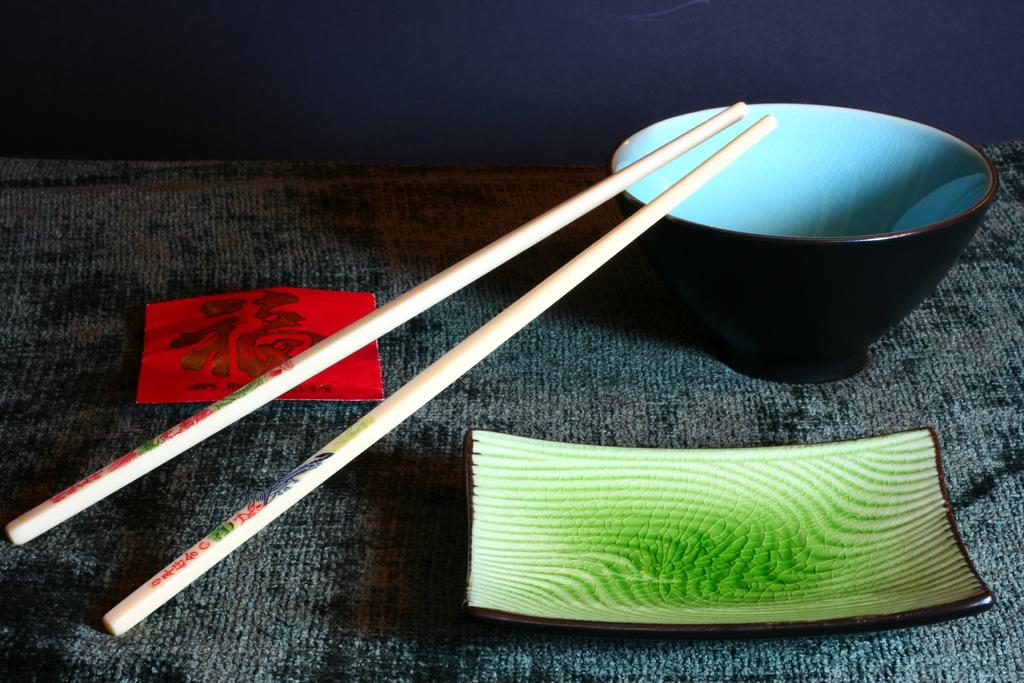What is on the bowl in the image? There are two chopsticks sliding on the bowl in the image. What else can be seen in the image besides the bowl? There is a plate in the image. Is there anything on the floor in the image? Yes, there is a tissue on the floor in the image. What type of wing can be seen flying in the image? There are no wings or flying objects present in the image. Can you describe the snake that is slithering on the plate in the image? There is no snake in the image; it only features a bowl with chopsticks and a plate. 